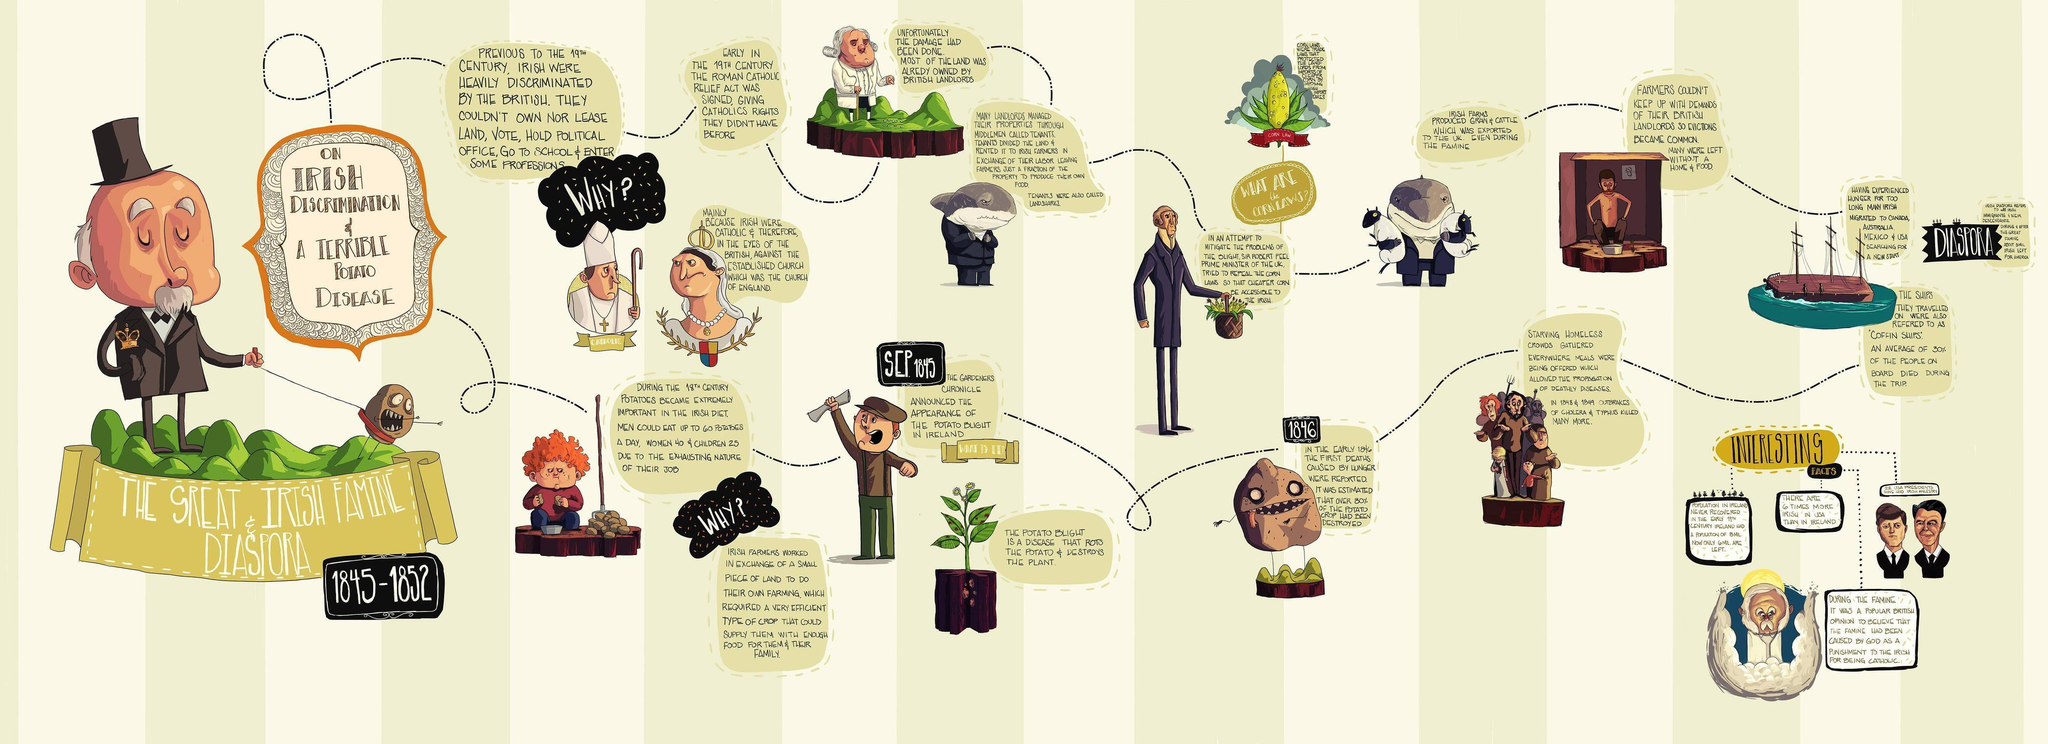Who were not able to own or lease land  or vote before the 19th century?
Answer the question with a short phrase. Irish What did the Irish farmers work in exchange for? a small piece of land to do their own farming Why were the Irish discriminated by the British? mainly because Irish were Catholic What disease rots the potato and destroys the plant? potato blight What was the purpose of the Roman Catholic relief Act? giving Catholics rights they didn't have before What was exported to UK from Irish farms? Grain, cattle Which other diseases killed many more people during the famine? Cholera, Typhus When did the potato blight appear in Ireland? Sep 1845 Who was the British Prime Minister during 1845-1846? Sir Robert Peel Who held ownership of majority of the land in Ireland? British landlords 